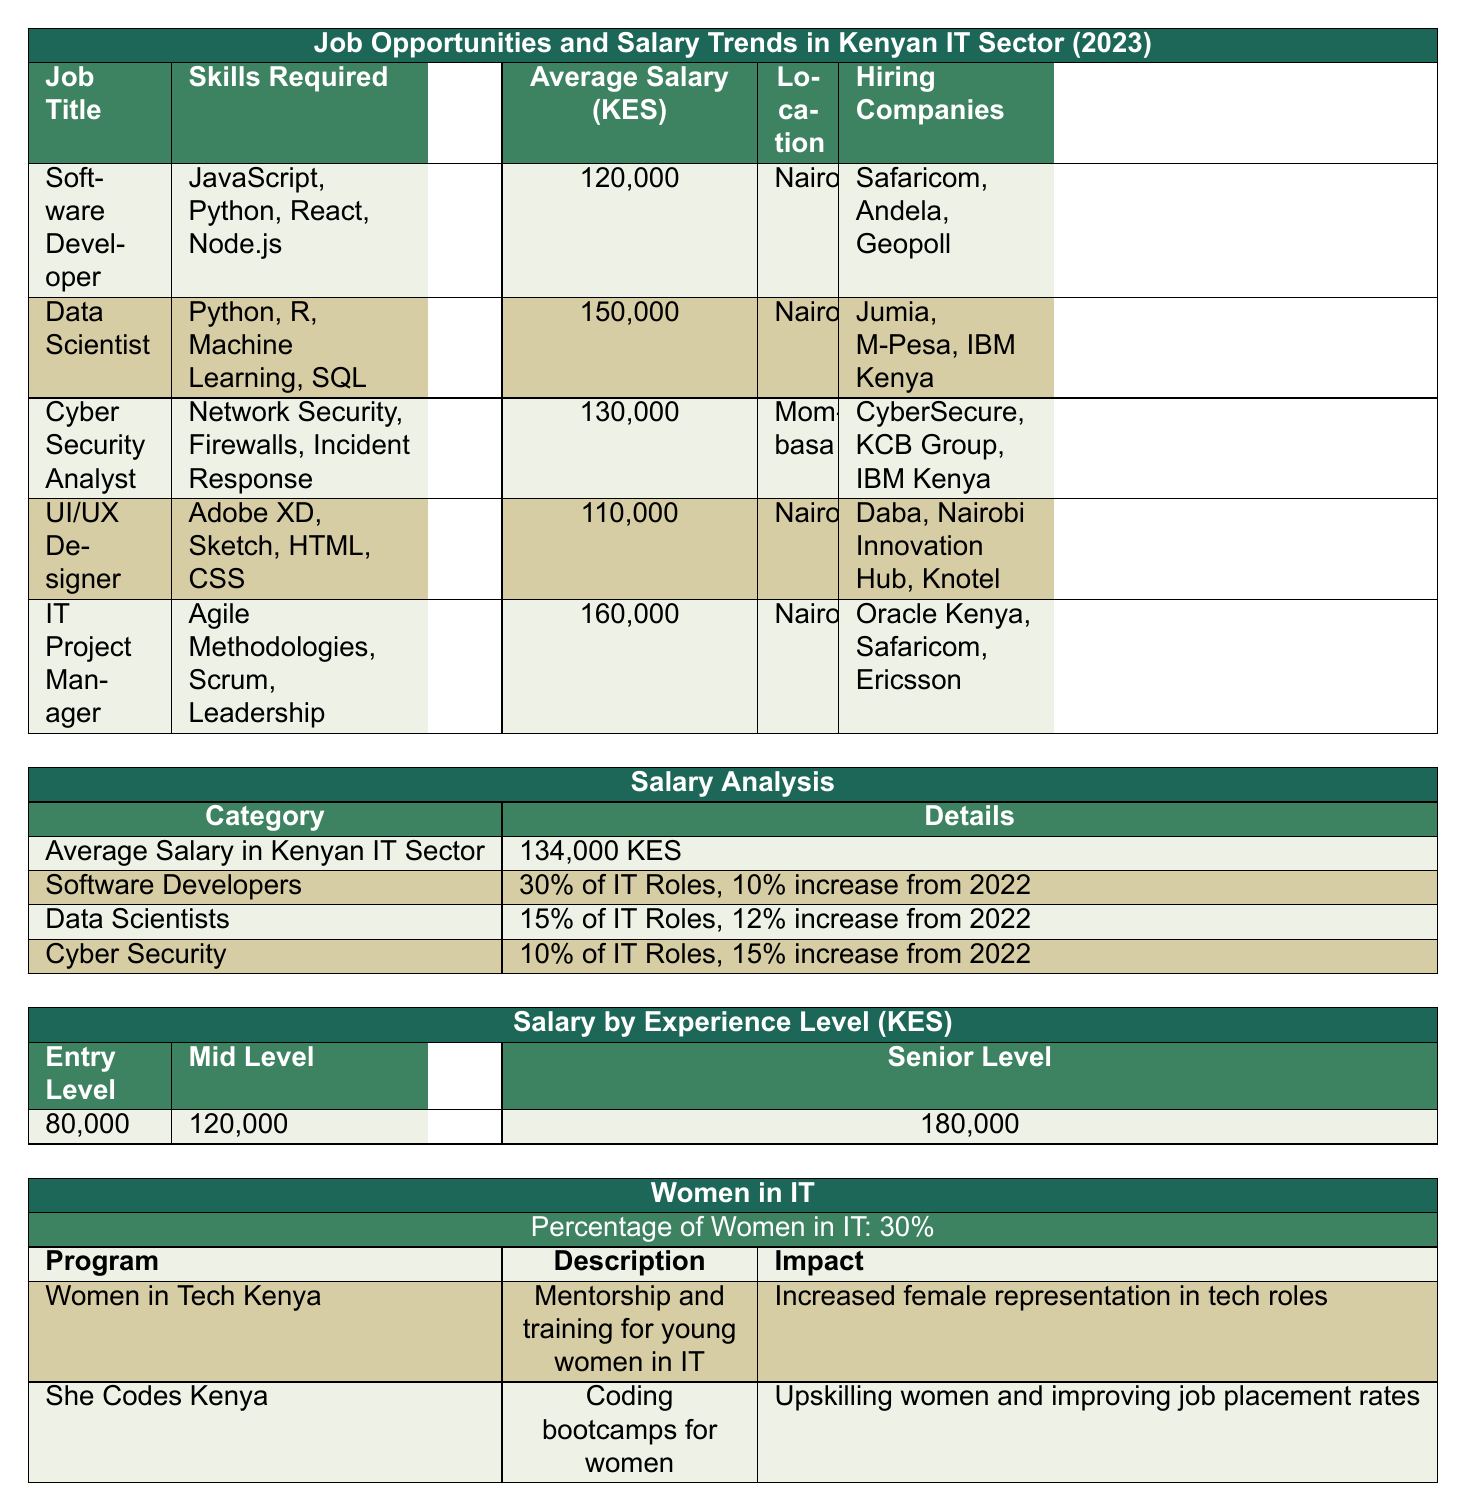What is the average salary of a Data Scientist in KES? The table states that the average salary for a Data Scientist is 150,000 KES.
Answer: 150,000 KES Which city has the highest average salary for IT roles? The table shows that the average salary for IT roles in Nairobi is higher than Mombasa, specifically for Software Developers, Data Scientists, and UI/UX Designers. The average salary in Nairobi is 120,000 KES, 150,000 KES, and 110,000 KES respectively, while Mombasa has 130,000 KES for Cyber Security Analysts. Hence, Nairobi has the highest average salary overall.
Answer: Nairobi What percentage of IT roles are occupied by Software Developers? The table indicates that Software Developers occupy 30% of IT roles in the Kenyan IT sector.
Answer: 30% What is the lowest average salary among the listed IT roles? The table lists the salaries for different roles: Software Developer (120,000 KES), Data Scientist (150,000 KES), Cyber Security Analyst (130,000 KES), UI/UX Designer (110,000 KES), and IT Project Manager (160,000 KES). The lowest value is 110,000 KES for a UI/UX Designer.
Answer: 110,000 KES If the growth trend for Data Scientists is 12% from 2022, what was their average salary in 2022? The average salary for Data Scientists in 2023 is 150,000 KES, and a 12% increase implies that this is 112% of the previous year's salary. To find the 2022 salary, we can divide 150,000 KES by 1.12, resulting in approximately 133,928 KES.
Answer: Approximately 133,928 KES Are there more women in IT or men, based on the data? The table shows that women make up 30% of the IT workforce, suggesting that men constitute the remaining 70%. Therefore, there are more men than women in IT.
Answer: No, there are more men in IT What is the average salary for an IT Project Manager in KES? According to the table, the average salary for an IT Project Manager is 160,000 KES.
Answer: 160,000 KES How many companies are hiring for the "Software Developer" position? The table lists three companies hiring for Software Developers: Safaricom, Andela, and Geopoll.
Answer: 3 companies What is the percentage increase in average salary for Cyber Security roles from 2022? The table states that there is a 15% increase for Cyber Security roles from 2022. This is a direct retrieval of the data provided in the table.
Answer: 15% What skills are necessary for a UI/UX Designer role? The required skills for a UI/UX Designer are mentioned in the table as Adobe XD, Sketch, HTML, and CSS.
Answer: Adobe XD, Sketch, HTML, CSS What are the total average salaries of all roles listed in the table? The average salaries for all listed roles are: Software Developer (120,000 KES), Data Scientist (150,000 KES), Cyber Security Analyst (130,000 KES), UI/UX Designer (110,000 KES), and IT Project Manager (160,000 KES). Adding these gives a total of 770,000 KES.
Answer: 770,000 KES 